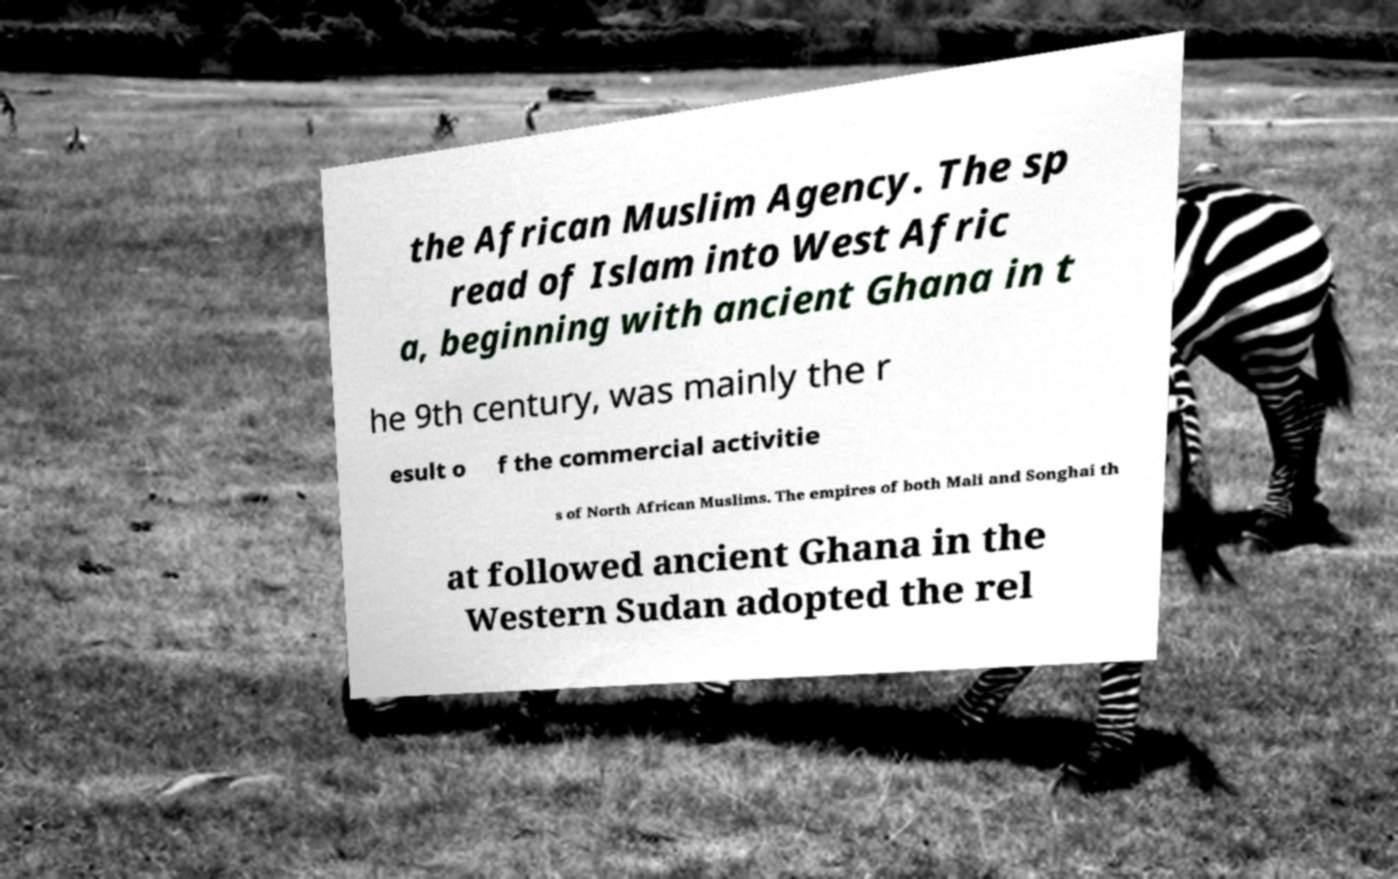Can you read and provide the text displayed in the image?This photo seems to have some interesting text. Can you extract and type it out for me? the African Muslim Agency. The sp read of Islam into West Afric a, beginning with ancient Ghana in t he 9th century, was mainly the r esult o f the commercial activitie s of North African Muslims. The empires of both Mali and Songhai th at followed ancient Ghana in the Western Sudan adopted the rel 